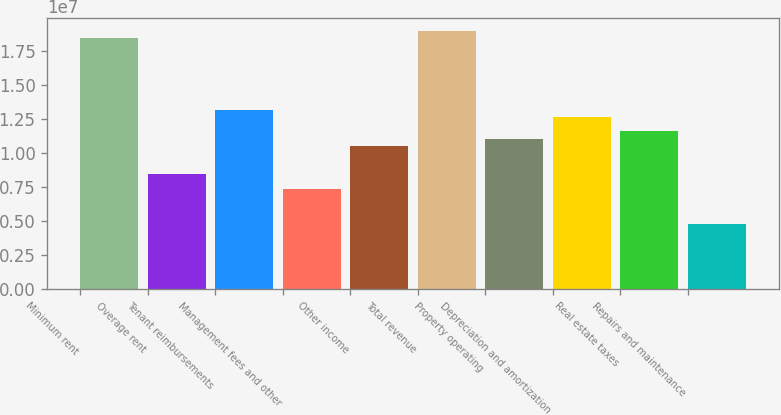<chart> <loc_0><loc_0><loc_500><loc_500><bar_chart><fcel>Minimum rent<fcel>Overage rent<fcel>Tenant reimbursements<fcel>Management fees and other<fcel>Other income<fcel>Total revenue<fcel>Property operating<fcel>Depreciation and amortization<fcel>Real estate taxes<fcel>Repairs and maintenance<nl><fcel>1.84239e+07<fcel>8.42397e+06<fcel>1.31608e+07<fcel>7.37135e+06<fcel>1.05292e+07<fcel>1.89502e+07<fcel>1.10555e+07<fcel>1.26345e+07<fcel>1.15818e+07<fcel>4.73979e+06<nl></chart> 